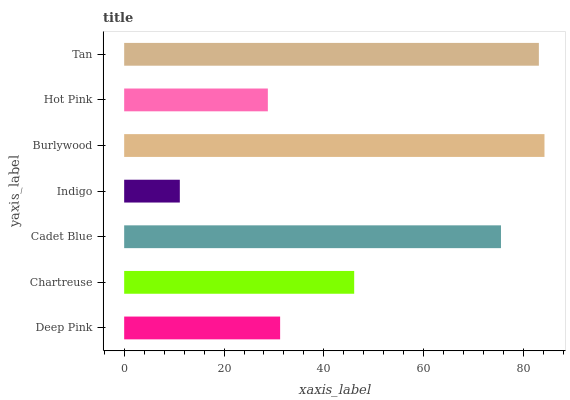Is Indigo the minimum?
Answer yes or no. Yes. Is Burlywood the maximum?
Answer yes or no. Yes. Is Chartreuse the minimum?
Answer yes or no. No. Is Chartreuse the maximum?
Answer yes or no. No. Is Chartreuse greater than Deep Pink?
Answer yes or no. Yes. Is Deep Pink less than Chartreuse?
Answer yes or no. Yes. Is Deep Pink greater than Chartreuse?
Answer yes or no. No. Is Chartreuse less than Deep Pink?
Answer yes or no. No. Is Chartreuse the high median?
Answer yes or no. Yes. Is Chartreuse the low median?
Answer yes or no. Yes. Is Hot Pink the high median?
Answer yes or no. No. Is Burlywood the low median?
Answer yes or no. No. 